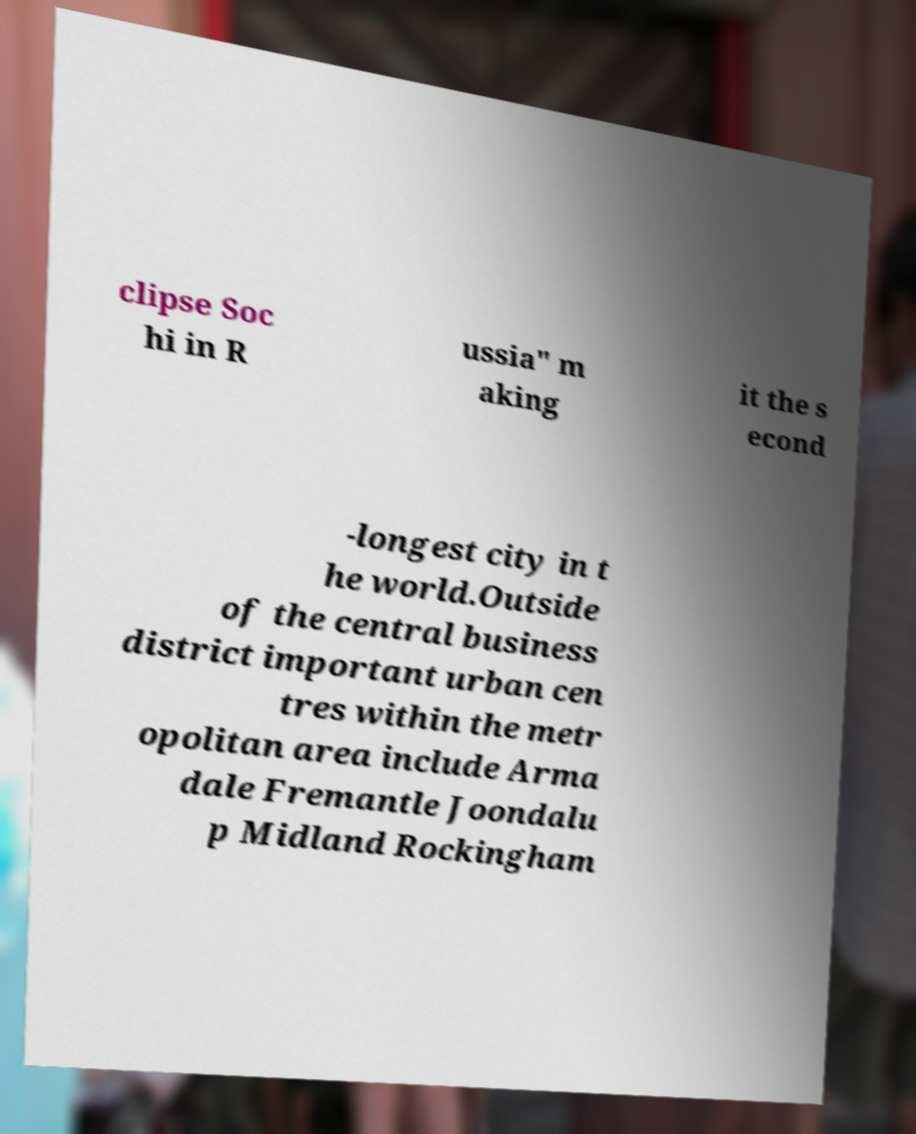What messages or text are displayed in this image? I need them in a readable, typed format. clipse Soc hi in R ussia" m aking it the s econd -longest city in t he world.Outside of the central business district important urban cen tres within the metr opolitan area include Arma dale Fremantle Joondalu p Midland Rockingham 